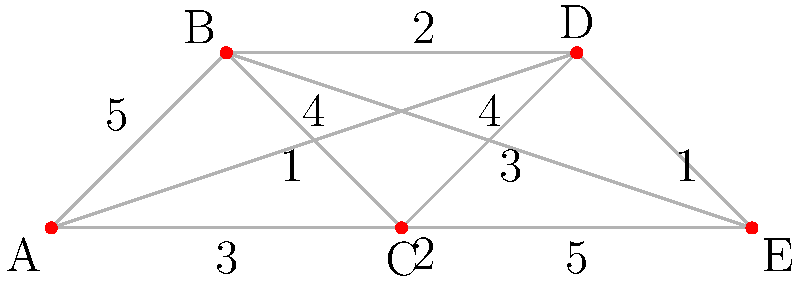In this social media influencer network, nodes represent influencers and edge weights represent their mutual influence strength. What is the minimum number of influencers needed to directly reach all others, and how does this challenge the notion of decentralized cultural trend-setting? To answer this question, we need to analyze the graph and find the minimum dominating set:

1. Examine each node's connections:
   A: connected to B(5), C(3), D(4), E(2)
   B: connected to A(5), C(1), D(2), E(3)
   C: connected to A(3), B(1), D(4), E(5)
   D: connected to A(4), B(2), C(4), E(1)
   E: connected to A(2), B(3), C(5), D(1)

2. Identify the node with the highest total influence:
   A: 5+3+4+2 = 14
   B: 5+1+2+3 = 11
   C: 3+1+4+5 = 13
   D: 4+2+4+1 = 11
   E: 2+3+5+1 = 11

   Node A has the highest total influence.

3. Select node A for the dominating set, as it reaches all other nodes directly.

4. The minimum dominating set consists of only node A, meaning the minimum number of influencers needed to directly reach all others is 1.

5. This challenges the notion of decentralized cultural trend-setting because:
   a) A single influencer (A) can directly reach and influence all others.
   b) It suggests a concentration of power in cultural trend-setting.
   c) It implies that cultural trends may be more centralized than commonly believed.
   d) It questions the idea of organic, grassroots cultural movements in the social media age.
Answer: 1 influencer; centralized trend-setting power 